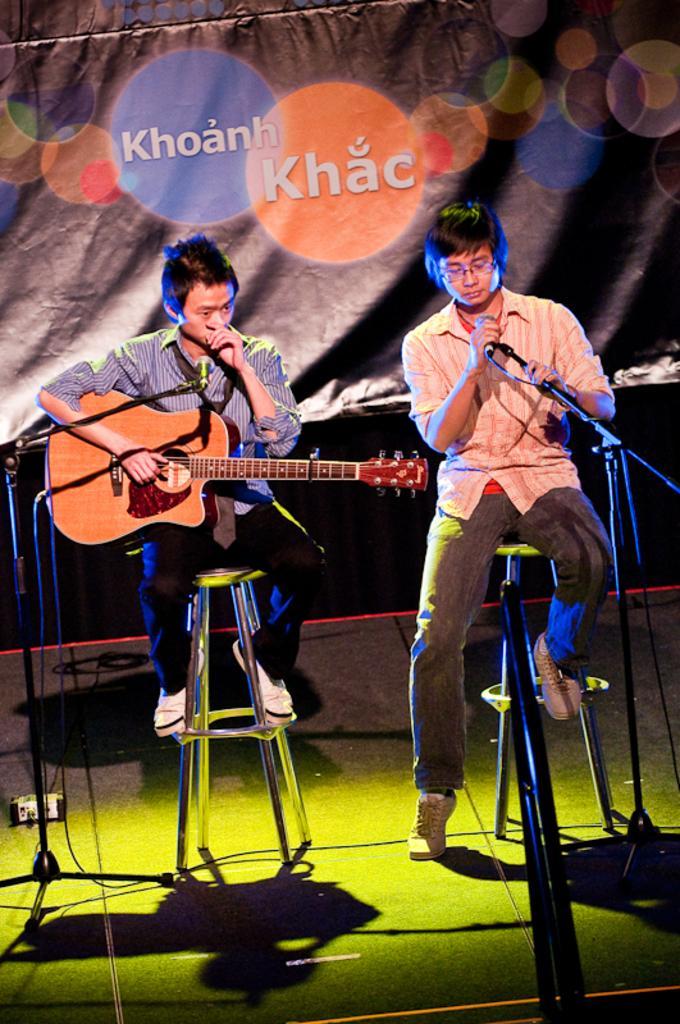How would you summarize this image in a sentence or two? This image is clicked in a concert. There are two men sitting on the stools and performing music. To the right, there is man sitting and wearing orange shirt is singing. To the left, the man is playing guitar. In the background, there is a banner. At the bottom, there is a floor. 